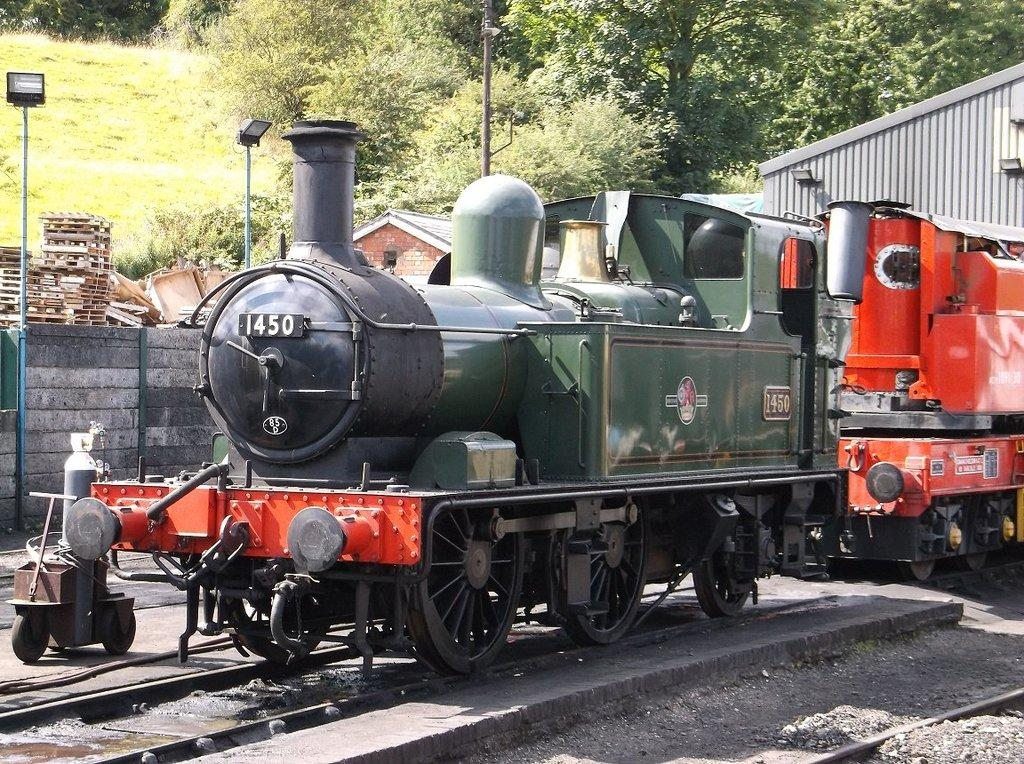Provide a one-sentence caption for the provided image. the old train 1450 is sitting on the track, likely for a tour. 